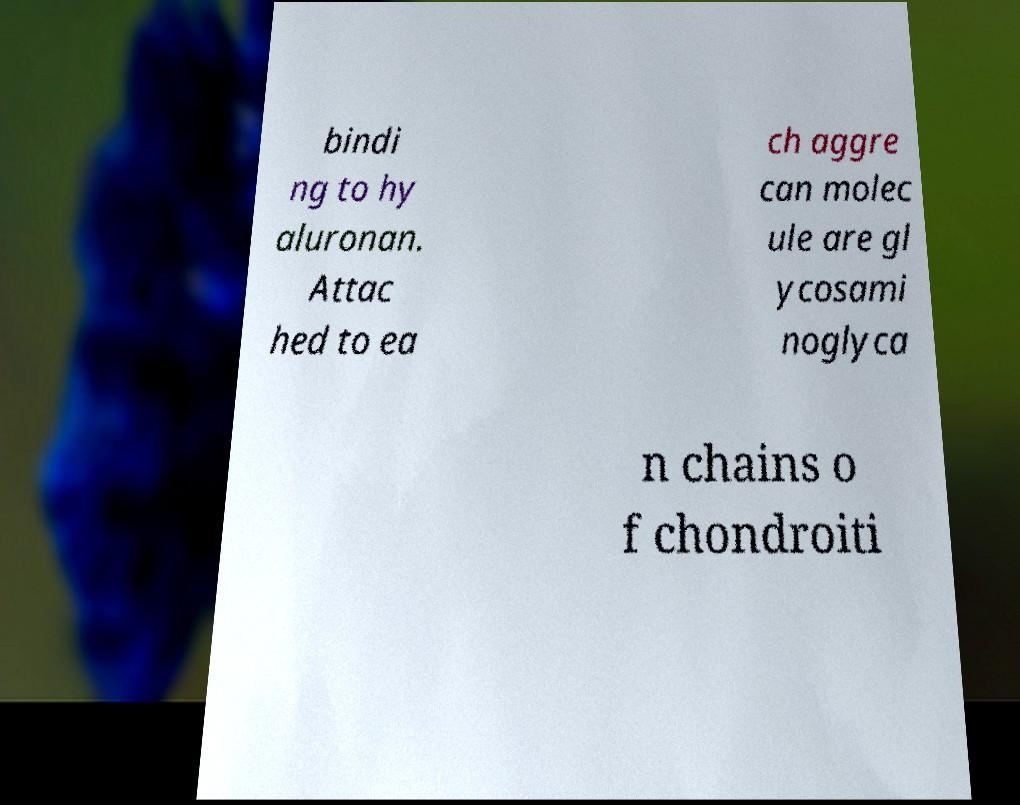Can you read and provide the text displayed in the image?This photo seems to have some interesting text. Can you extract and type it out for me? bindi ng to hy aluronan. Attac hed to ea ch aggre can molec ule are gl ycosami noglyca n chains o f chondroiti 